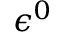Convert formula to latex. <formula><loc_0><loc_0><loc_500><loc_500>\epsilon ^ { 0 }</formula> 